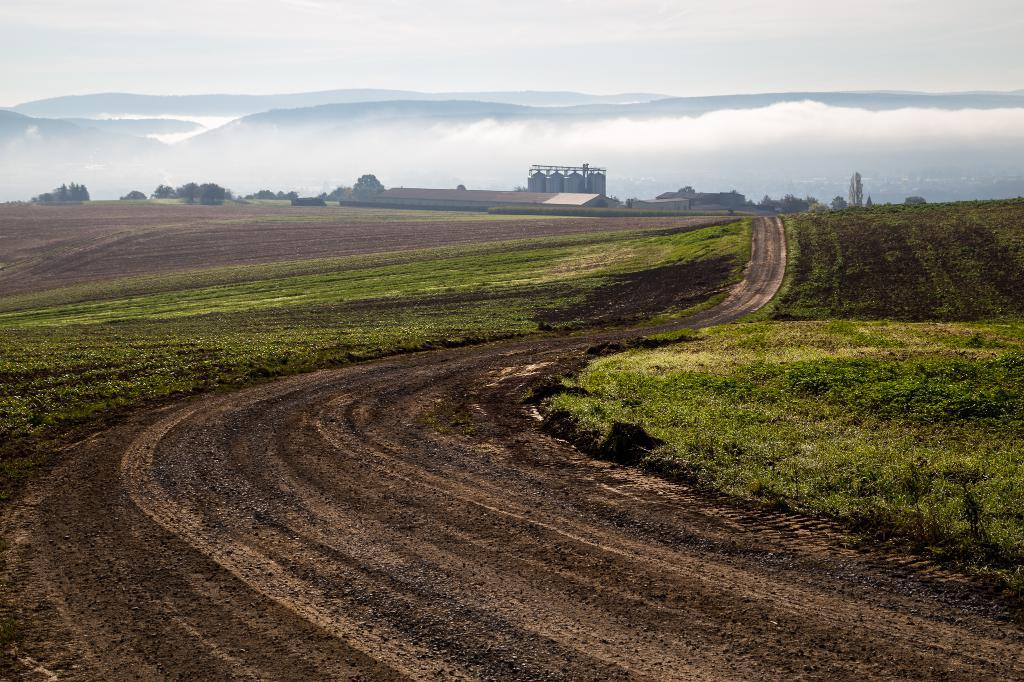What type of landscape is shown in the image? There is open land in the image. What can be seen in the distance behind the open land? There is an industry and mountains visible in the background of the image. What is the condition of the sky in the image? The sky is clear in the image. What song is being sung by the chicken in the image? There is no chicken present in the image, and therefore no song can be heard. 